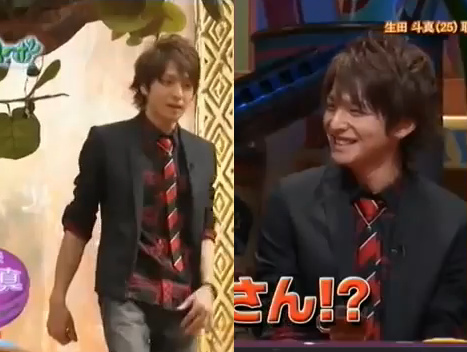Is the young man wearing a cap? No, the young man is not wearing a cap. 